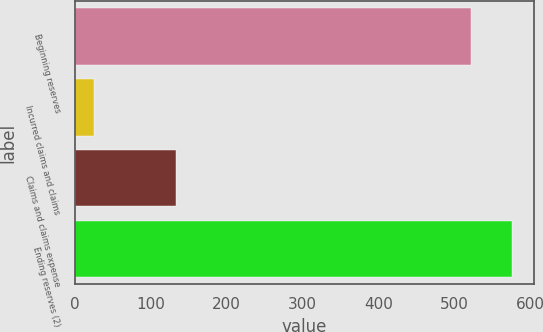Convert chart to OTSL. <chart><loc_0><loc_0><loc_500><loc_500><bar_chart><fcel>Beginning reserves<fcel>Incurred claims and claims<fcel>Claims and claims expense<fcel>Ending reserves (2)<nl><fcel>522<fcel>25<fcel>133<fcel>576<nl></chart> 